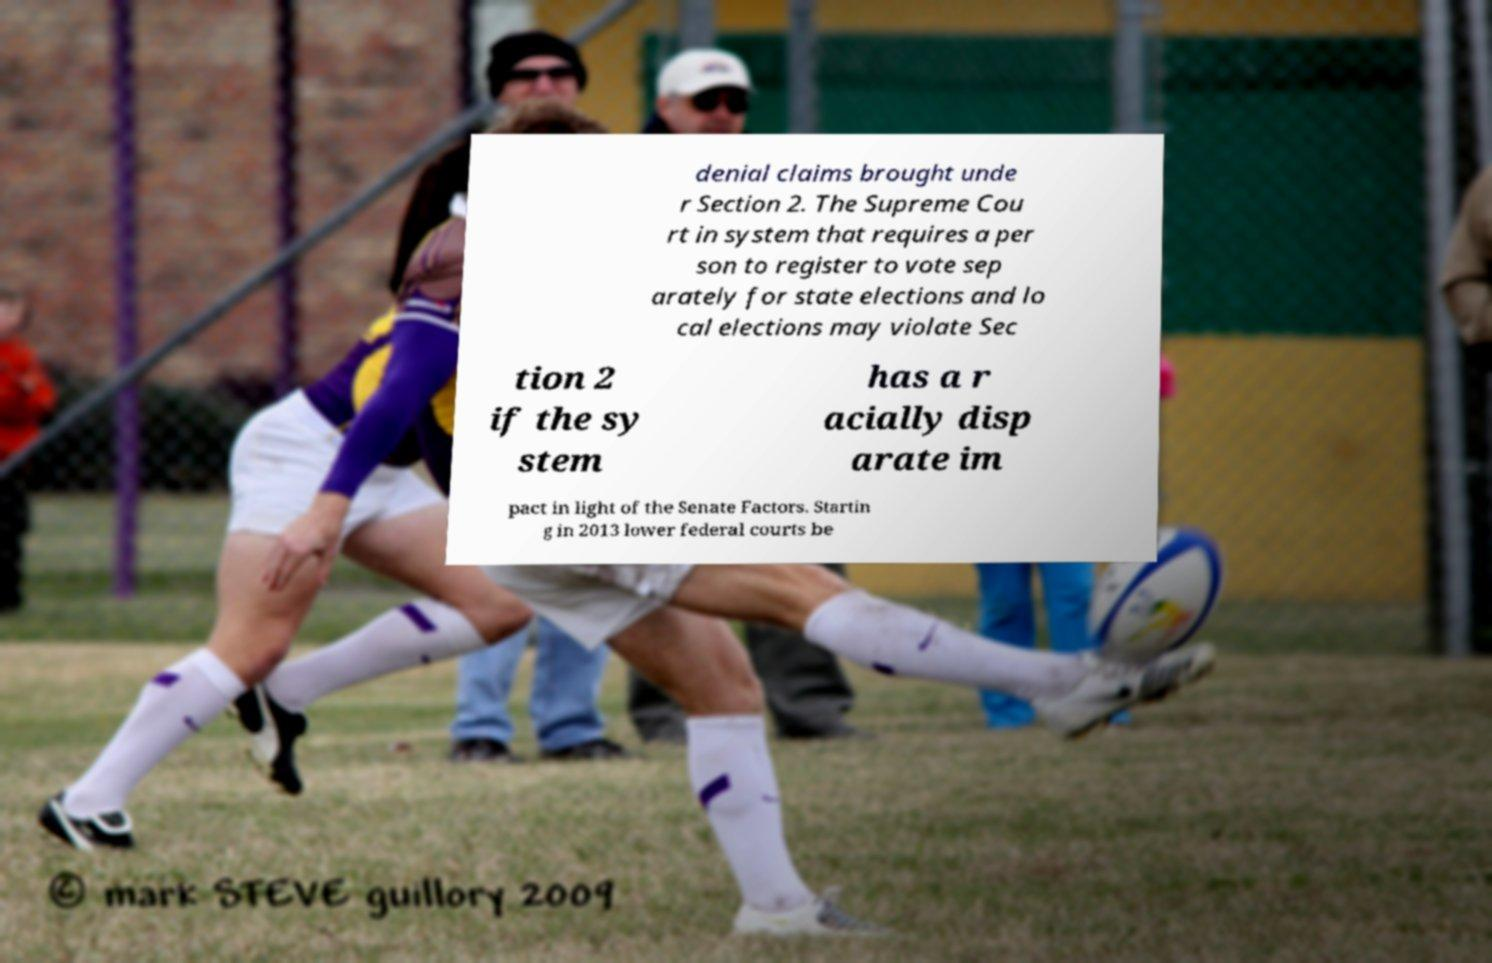There's text embedded in this image that I need extracted. Can you transcribe it verbatim? denial claims brought unde r Section 2. The Supreme Cou rt in system that requires a per son to register to vote sep arately for state elections and lo cal elections may violate Sec tion 2 if the sy stem has a r acially disp arate im pact in light of the Senate Factors. Startin g in 2013 lower federal courts be 